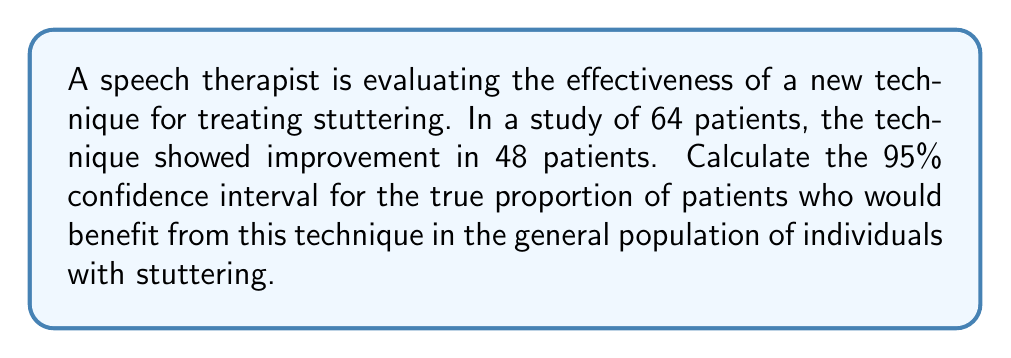Solve this math problem. To calculate the confidence interval, we'll use the following steps:

1. Calculate the sample proportion:
   $\hat{p} = \frac{\text{number of successes}}{\text{total number of trials}} = \frac{48}{64} = 0.75$

2. Calculate the standard error:
   $SE = \sqrt{\frac{\hat{p}(1-\hat{p})}{n}} = \sqrt{\frac{0.75(1-0.75)}{64}} = 0.0541$

3. For a 95% confidence interval, use $z_{0.025} = 1.96$ (from the standard normal distribution table)

4. Calculate the margin of error:
   $E = z_{0.025} \times SE = 1.96 \times 0.0541 = 0.1060$

5. Determine the confidence interval:
   Lower bound: $\hat{p} - E = 0.75 - 0.1060 = 0.6440$
   Upper bound: $\hat{p} + E = 0.75 + 0.1060 = 0.8560$

Therefore, the 95% confidence interval is (0.6440, 0.8560) or (64.40%, 85.60%).

This means we can be 95% confident that the true proportion of patients who would benefit from this technique in the general population of individuals with stuttering falls between 64.40% and 85.60%.
Answer: (0.6440, 0.8560) or (64.40%, 85.60%) 